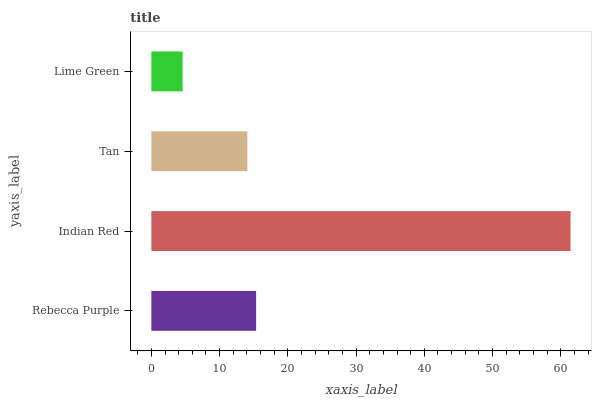Is Lime Green the minimum?
Answer yes or no. Yes. Is Indian Red the maximum?
Answer yes or no. Yes. Is Tan the minimum?
Answer yes or no. No. Is Tan the maximum?
Answer yes or no. No. Is Indian Red greater than Tan?
Answer yes or no. Yes. Is Tan less than Indian Red?
Answer yes or no. Yes. Is Tan greater than Indian Red?
Answer yes or no. No. Is Indian Red less than Tan?
Answer yes or no. No. Is Rebecca Purple the high median?
Answer yes or no. Yes. Is Tan the low median?
Answer yes or no. Yes. Is Tan the high median?
Answer yes or no. No. Is Rebecca Purple the low median?
Answer yes or no. No. 